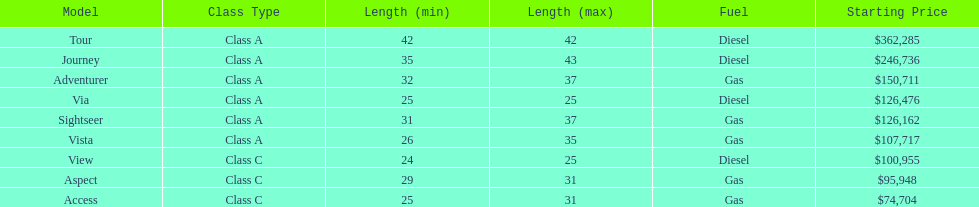What is the total number of class a models? 6. 